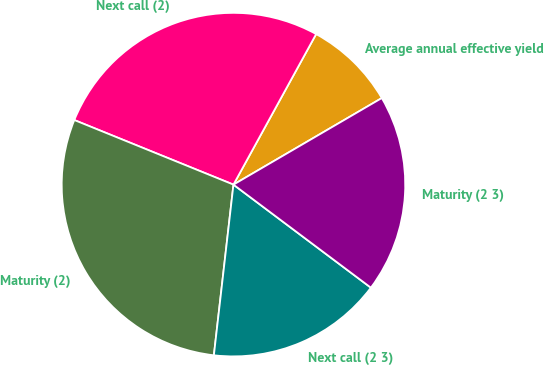Convert chart to OTSL. <chart><loc_0><loc_0><loc_500><loc_500><pie_chart><fcel>Average annual effective yield<fcel>Next call (2)<fcel>Maturity (2)<fcel>Next call (2 3)<fcel>Maturity (2 3)<nl><fcel>8.6%<fcel>26.86%<fcel>29.32%<fcel>16.58%<fcel>18.65%<nl></chart> 